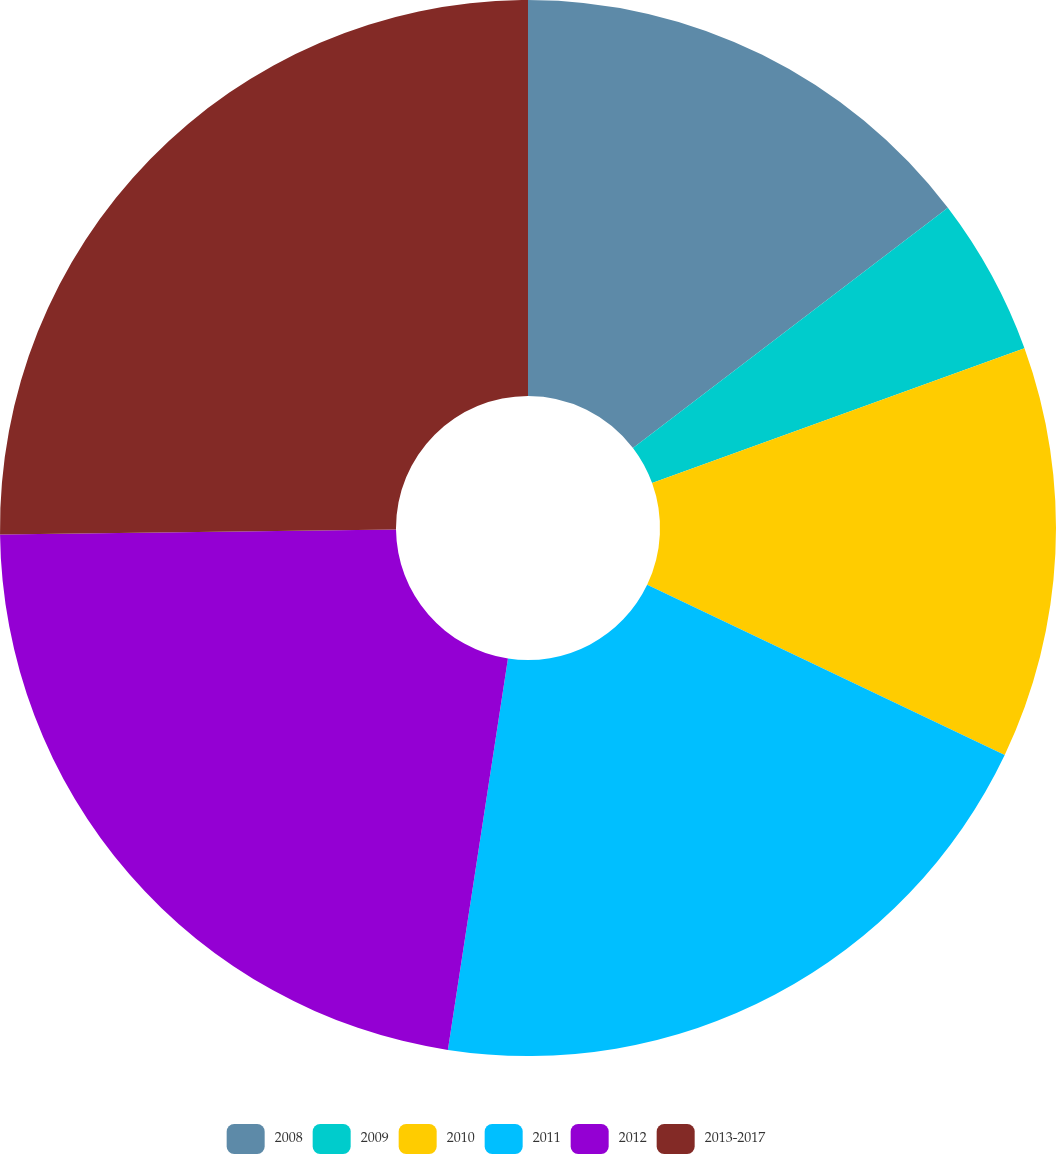<chart> <loc_0><loc_0><loc_500><loc_500><pie_chart><fcel>2008<fcel>2009<fcel>2010<fcel>2011<fcel>2012<fcel>2013-2017<nl><fcel>14.63%<fcel>4.84%<fcel>12.6%<fcel>20.35%<fcel>22.38%<fcel>25.19%<nl></chart> 